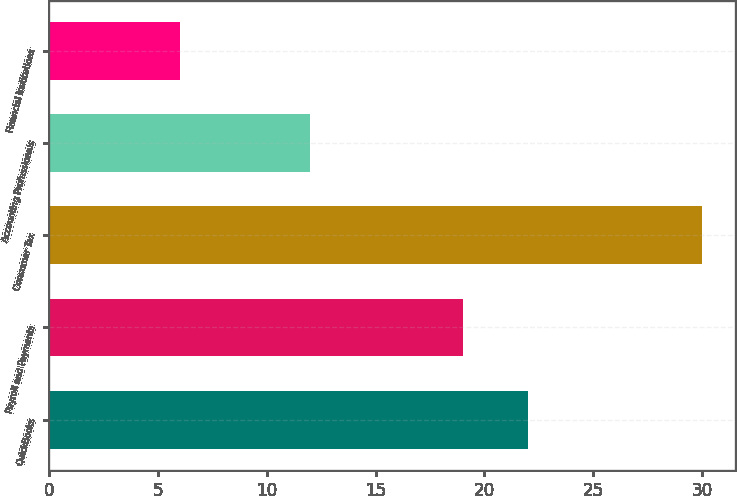Convert chart to OTSL. <chart><loc_0><loc_0><loc_500><loc_500><bar_chart><fcel>QuickBooks<fcel>Payroll and Payments<fcel>Consumer Tax<fcel>Accounting Professionals<fcel>Financial Institutions<nl><fcel>22<fcel>19<fcel>30<fcel>12<fcel>6<nl></chart> 